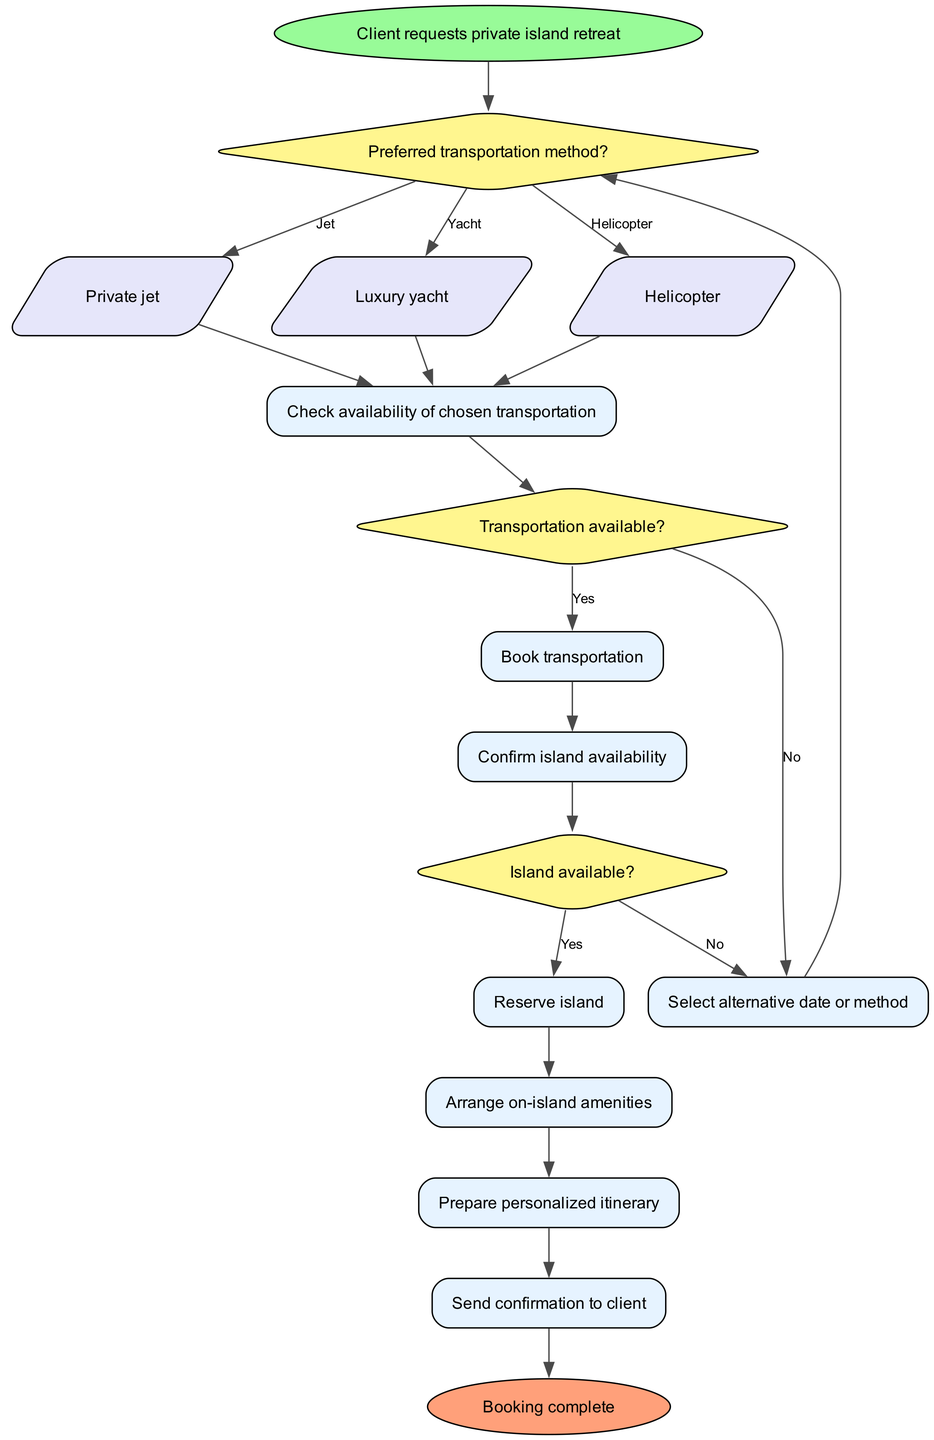What is the first step in the booking process? The first step in the booking process is when a client requests a private island retreat. This information is shown in the "start" node of the diagram.
Answer: Client requests private island retreat How many transportation options are available? There are three transportation options available as indicated by the options branching from the decision node that asks for the preferred transportation method. These options are private jet, luxury yacht, and helicopter.
Answer: 3 What happens if the chosen transportation is not available? If the chosen transportation is not available, the process leads to selecting an alternative date or method. This is shown in the flow starting from the decision node for transportation availability.
Answer: Select alternative date or method What is the process if the island is available? If the island is available, the process proceeds to reserve the island, arrange on-island amenities, prepare a personalized itinerary, and then send a confirmation to the client. This shows a sequence of actions directly following the decision that checks island availability.
Answer: Reserve island, arrange on-island amenities, prepare personalized itinerary, send confirmation What color represents decision nodes in the diagram? Decision nodes are represented in yellow, which is indicated by the fill color in the diagram for nodes that ask questions that lead to different paths based on yes/no answers.
Answer: Yellow What follows after confirming island availability? After confirming island availability, the process continues to reserve the island. This is the next step described after the decision that checks the island's availability.
Answer: Reserve island What is the last step in the booking process? The last step in the booking process is sending confirmation to the client. This is the final action before reaching the end node of the diagram.
Answer: Send confirmation to client How does the process begin regarding transportation? The process begins by asking the client for their preferred method of transportation, as indicated in the decision1 node. This sets the stage for proceeding with the booking requirements based on the client's choice.
Answer: Preferred transportation method? If transportation is booked successfully, which step directly follows? If transportation is booked successfully, the next step is confirming the availability of the island. This is illustrated in the flow directly after the booking of transportation is completed.
Answer: Confirm island availability 